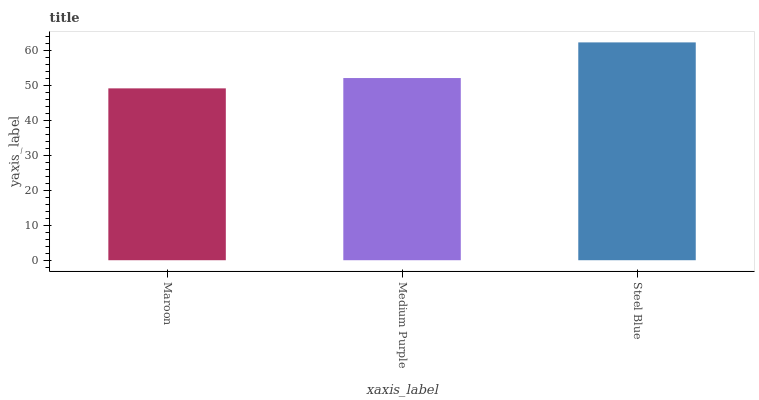Is Maroon the minimum?
Answer yes or no. Yes. Is Steel Blue the maximum?
Answer yes or no. Yes. Is Medium Purple the minimum?
Answer yes or no. No. Is Medium Purple the maximum?
Answer yes or no. No. Is Medium Purple greater than Maroon?
Answer yes or no. Yes. Is Maroon less than Medium Purple?
Answer yes or no. Yes. Is Maroon greater than Medium Purple?
Answer yes or no. No. Is Medium Purple less than Maroon?
Answer yes or no. No. Is Medium Purple the high median?
Answer yes or no. Yes. Is Medium Purple the low median?
Answer yes or no. Yes. Is Maroon the high median?
Answer yes or no. No. Is Maroon the low median?
Answer yes or no. No. 